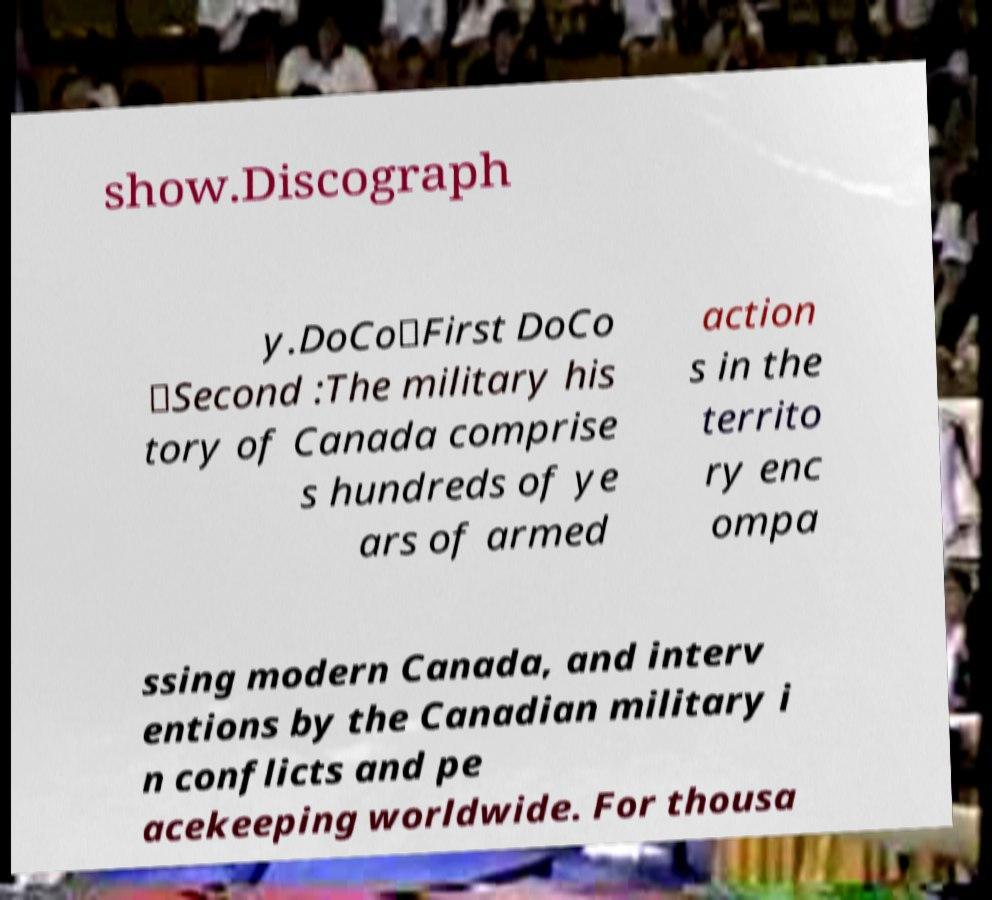There's text embedded in this image that I need extracted. Can you transcribe it verbatim? show.Discograph y.DoCo★First DoCo ☆Second :The military his tory of Canada comprise s hundreds of ye ars of armed action s in the territo ry enc ompa ssing modern Canada, and interv entions by the Canadian military i n conflicts and pe acekeeping worldwide. For thousa 